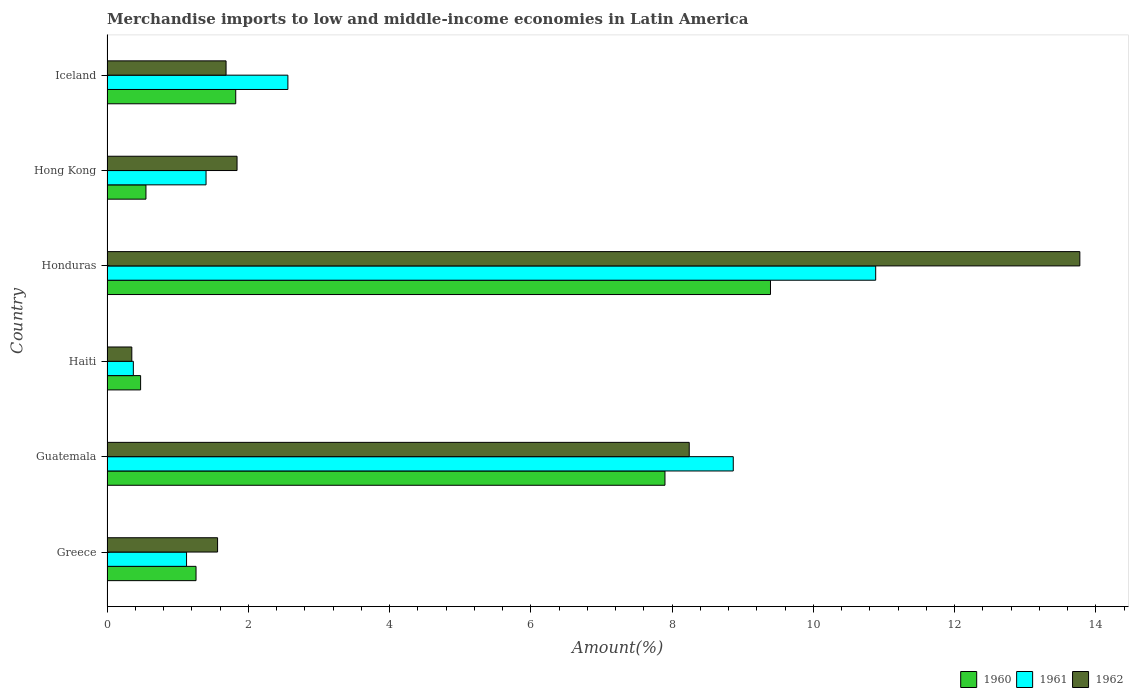How many different coloured bars are there?
Your answer should be compact. 3. How many groups of bars are there?
Make the answer very short. 6. How many bars are there on the 6th tick from the top?
Your answer should be very brief. 3. What is the label of the 2nd group of bars from the top?
Provide a short and direct response. Hong Kong. What is the percentage of amount earned from merchandise imports in 1962 in Haiti?
Provide a short and direct response. 0.35. Across all countries, what is the maximum percentage of amount earned from merchandise imports in 1962?
Your response must be concise. 13.77. Across all countries, what is the minimum percentage of amount earned from merchandise imports in 1961?
Offer a terse response. 0.37. In which country was the percentage of amount earned from merchandise imports in 1960 maximum?
Ensure brevity in your answer.  Honduras. In which country was the percentage of amount earned from merchandise imports in 1962 minimum?
Make the answer very short. Haiti. What is the total percentage of amount earned from merchandise imports in 1960 in the graph?
Your response must be concise. 21.4. What is the difference between the percentage of amount earned from merchandise imports in 1960 in Greece and that in Honduras?
Provide a short and direct response. -8.13. What is the difference between the percentage of amount earned from merchandise imports in 1960 in Honduras and the percentage of amount earned from merchandise imports in 1962 in Iceland?
Offer a terse response. 7.71. What is the average percentage of amount earned from merchandise imports in 1961 per country?
Make the answer very short. 4.2. What is the difference between the percentage of amount earned from merchandise imports in 1962 and percentage of amount earned from merchandise imports in 1960 in Hong Kong?
Your answer should be very brief. 1.29. In how many countries, is the percentage of amount earned from merchandise imports in 1961 greater than 0.4 %?
Ensure brevity in your answer.  5. What is the ratio of the percentage of amount earned from merchandise imports in 1962 in Greece to that in Honduras?
Provide a succinct answer. 0.11. Is the percentage of amount earned from merchandise imports in 1960 in Haiti less than that in Hong Kong?
Your answer should be very brief. Yes. Is the difference between the percentage of amount earned from merchandise imports in 1962 in Greece and Honduras greater than the difference between the percentage of amount earned from merchandise imports in 1960 in Greece and Honduras?
Give a very brief answer. No. What is the difference between the highest and the second highest percentage of amount earned from merchandise imports in 1962?
Keep it short and to the point. 5.53. What is the difference between the highest and the lowest percentage of amount earned from merchandise imports in 1962?
Make the answer very short. 13.42. What does the 2nd bar from the top in Haiti represents?
Keep it short and to the point. 1961. How many bars are there?
Give a very brief answer. 18. Are all the bars in the graph horizontal?
Provide a short and direct response. Yes. How many countries are there in the graph?
Offer a terse response. 6. Does the graph contain any zero values?
Your answer should be compact. No. What is the title of the graph?
Make the answer very short. Merchandise imports to low and middle-income economies in Latin America. Does "2006" appear as one of the legend labels in the graph?
Your answer should be compact. No. What is the label or title of the X-axis?
Offer a terse response. Amount(%). What is the Amount(%) in 1960 in Greece?
Your response must be concise. 1.26. What is the Amount(%) of 1961 in Greece?
Provide a succinct answer. 1.13. What is the Amount(%) of 1962 in Greece?
Keep it short and to the point. 1.57. What is the Amount(%) in 1960 in Guatemala?
Make the answer very short. 7.9. What is the Amount(%) in 1961 in Guatemala?
Your response must be concise. 8.87. What is the Amount(%) of 1962 in Guatemala?
Offer a terse response. 8.24. What is the Amount(%) in 1960 in Haiti?
Give a very brief answer. 0.48. What is the Amount(%) of 1961 in Haiti?
Give a very brief answer. 0.37. What is the Amount(%) in 1962 in Haiti?
Ensure brevity in your answer.  0.35. What is the Amount(%) of 1960 in Honduras?
Offer a terse response. 9.39. What is the Amount(%) of 1961 in Honduras?
Offer a very short reply. 10.88. What is the Amount(%) in 1962 in Honduras?
Give a very brief answer. 13.77. What is the Amount(%) of 1960 in Hong Kong?
Keep it short and to the point. 0.55. What is the Amount(%) in 1961 in Hong Kong?
Offer a very short reply. 1.4. What is the Amount(%) of 1962 in Hong Kong?
Your answer should be compact. 1.84. What is the Amount(%) in 1960 in Iceland?
Your answer should be very brief. 1.82. What is the Amount(%) in 1961 in Iceland?
Ensure brevity in your answer.  2.56. What is the Amount(%) in 1962 in Iceland?
Provide a short and direct response. 1.69. Across all countries, what is the maximum Amount(%) of 1960?
Keep it short and to the point. 9.39. Across all countries, what is the maximum Amount(%) in 1961?
Make the answer very short. 10.88. Across all countries, what is the maximum Amount(%) in 1962?
Offer a terse response. 13.77. Across all countries, what is the minimum Amount(%) of 1960?
Offer a very short reply. 0.48. Across all countries, what is the minimum Amount(%) of 1961?
Offer a terse response. 0.37. Across all countries, what is the minimum Amount(%) of 1962?
Keep it short and to the point. 0.35. What is the total Amount(%) in 1960 in the graph?
Ensure brevity in your answer.  21.4. What is the total Amount(%) in 1961 in the graph?
Your response must be concise. 25.21. What is the total Amount(%) of 1962 in the graph?
Your response must be concise. 27.46. What is the difference between the Amount(%) of 1960 in Greece and that in Guatemala?
Give a very brief answer. -6.64. What is the difference between the Amount(%) of 1961 in Greece and that in Guatemala?
Keep it short and to the point. -7.74. What is the difference between the Amount(%) of 1962 in Greece and that in Guatemala?
Ensure brevity in your answer.  -6.68. What is the difference between the Amount(%) in 1960 in Greece and that in Haiti?
Provide a succinct answer. 0.78. What is the difference between the Amount(%) in 1961 in Greece and that in Haiti?
Your answer should be very brief. 0.75. What is the difference between the Amount(%) in 1962 in Greece and that in Haiti?
Offer a very short reply. 1.21. What is the difference between the Amount(%) in 1960 in Greece and that in Honduras?
Your answer should be compact. -8.13. What is the difference between the Amount(%) of 1961 in Greece and that in Honduras?
Your response must be concise. -9.76. What is the difference between the Amount(%) of 1962 in Greece and that in Honduras?
Your answer should be very brief. -12.21. What is the difference between the Amount(%) of 1960 in Greece and that in Hong Kong?
Provide a short and direct response. 0.71. What is the difference between the Amount(%) of 1961 in Greece and that in Hong Kong?
Provide a succinct answer. -0.28. What is the difference between the Amount(%) in 1962 in Greece and that in Hong Kong?
Give a very brief answer. -0.28. What is the difference between the Amount(%) in 1960 in Greece and that in Iceland?
Make the answer very short. -0.56. What is the difference between the Amount(%) of 1961 in Greece and that in Iceland?
Offer a very short reply. -1.43. What is the difference between the Amount(%) of 1962 in Greece and that in Iceland?
Provide a succinct answer. -0.12. What is the difference between the Amount(%) of 1960 in Guatemala and that in Haiti?
Your answer should be compact. 7.42. What is the difference between the Amount(%) of 1961 in Guatemala and that in Haiti?
Ensure brevity in your answer.  8.49. What is the difference between the Amount(%) of 1962 in Guatemala and that in Haiti?
Provide a short and direct response. 7.89. What is the difference between the Amount(%) of 1960 in Guatemala and that in Honduras?
Provide a short and direct response. -1.49. What is the difference between the Amount(%) in 1961 in Guatemala and that in Honduras?
Keep it short and to the point. -2.02. What is the difference between the Amount(%) in 1962 in Guatemala and that in Honduras?
Provide a short and direct response. -5.53. What is the difference between the Amount(%) in 1960 in Guatemala and that in Hong Kong?
Provide a succinct answer. 7.35. What is the difference between the Amount(%) of 1961 in Guatemala and that in Hong Kong?
Offer a terse response. 7.46. What is the difference between the Amount(%) of 1962 in Guatemala and that in Hong Kong?
Your answer should be very brief. 6.4. What is the difference between the Amount(%) in 1960 in Guatemala and that in Iceland?
Your answer should be very brief. 6.08. What is the difference between the Amount(%) of 1961 in Guatemala and that in Iceland?
Your response must be concise. 6.3. What is the difference between the Amount(%) of 1962 in Guatemala and that in Iceland?
Provide a succinct answer. 6.56. What is the difference between the Amount(%) of 1960 in Haiti and that in Honduras?
Provide a short and direct response. -8.92. What is the difference between the Amount(%) in 1961 in Haiti and that in Honduras?
Offer a terse response. -10.51. What is the difference between the Amount(%) in 1962 in Haiti and that in Honduras?
Make the answer very short. -13.42. What is the difference between the Amount(%) in 1960 in Haiti and that in Hong Kong?
Provide a short and direct response. -0.08. What is the difference between the Amount(%) of 1961 in Haiti and that in Hong Kong?
Ensure brevity in your answer.  -1.03. What is the difference between the Amount(%) of 1962 in Haiti and that in Hong Kong?
Ensure brevity in your answer.  -1.49. What is the difference between the Amount(%) of 1960 in Haiti and that in Iceland?
Your answer should be compact. -1.35. What is the difference between the Amount(%) of 1961 in Haiti and that in Iceland?
Make the answer very short. -2.19. What is the difference between the Amount(%) in 1962 in Haiti and that in Iceland?
Your answer should be very brief. -1.33. What is the difference between the Amount(%) of 1960 in Honduras and that in Hong Kong?
Provide a short and direct response. 8.84. What is the difference between the Amount(%) in 1961 in Honduras and that in Hong Kong?
Keep it short and to the point. 9.48. What is the difference between the Amount(%) in 1962 in Honduras and that in Hong Kong?
Offer a very short reply. 11.93. What is the difference between the Amount(%) of 1960 in Honduras and that in Iceland?
Your response must be concise. 7.57. What is the difference between the Amount(%) of 1961 in Honduras and that in Iceland?
Offer a terse response. 8.32. What is the difference between the Amount(%) of 1962 in Honduras and that in Iceland?
Your response must be concise. 12.09. What is the difference between the Amount(%) in 1960 in Hong Kong and that in Iceland?
Your answer should be very brief. -1.27. What is the difference between the Amount(%) of 1961 in Hong Kong and that in Iceland?
Your answer should be compact. -1.16. What is the difference between the Amount(%) in 1962 in Hong Kong and that in Iceland?
Your answer should be compact. 0.16. What is the difference between the Amount(%) of 1960 in Greece and the Amount(%) of 1961 in Guatemala?
Provide a succinct answer. -7.61. What is the difference between the Amount(%) in 1960 in Greece and the Amount(%) in 1962 in Guatemala?
Your response must be concise. -6.98. What is the difference between the Amount(%) in 1961 in Greece and the Amount(%) in 1962 in Guatemala?
Your answer should be compact. -7.12. What is the difference between the Amount(%) in 1960 in Greece and the Amount(%) in 1961 in Haiti?
Give a very brief answer. 0.89. What is the difference between the Amount(%) of 1960 in Greece and the Amount(%) of 1962 in Haiti?
Offer a very short reply. 0.91. What is the difference between the Amount(%) in 1961 in Greece and the Amount(%) in 1962 in Haiti?
Offer a very short reply. 0.77. What is the difference between the Amount(%) in 1960 in Greece and the Amount(%) in 1961 in Honduras?
Offer a terse response. -9.62. What is the difference between the Amount(%) of 1960 in Greece and the Amount(%) of 1962 in Honduras?
Give a very brief answer. -12.51. What is the difference between the Amount(%) of 1961 in Greece and the Amount(%) of 1962 in Honduras?
Ensure brevity in your answer.  -12.65. What is the difference between the Amount(%) of 1960 in Greece and the Amount(%) of 1961 in Hong Kong?
Offer a terse response. -0.14. What is the difference between the Amount(%) of 1960 in Greece and the Amount(%) of 1962 in Hong Kong?
Your answer should be very brief. -0.58. What is the difference between the Amount(%) of 1961 in Greece and the Amount(%) of 1962 in Hong Kong?
Offer a very short reply. -0.71. What is the difference between the Amount(%) of 1960 in Greece and the Amount(%) of 1961 in Iceland?
Your response must be concise. -1.3. What is the difference between the Amount(%) in 1960 in Greece and the Amount(%) in 1962 in Iceland?
Keep it short and to the point. -0.43. What is the difference between the Amount(%) of 1961 in Greece and the Amount(%) of 1962 in Iceland?
Offer a terse response. -0.56. What is the difference between the Amount(%) in 1960 in Guatemala and the Amount(%) in 1961 in Haiti?
Your response must be concise. 7.53. What is the difference between the Amount(%) in 1960 in Guatemala and the Amount(%) in 1962 in Haiti?
Your response must be concise. 7.55. What is the difference between the Amount(%) in 1961 in Guatemala and the Amount(%) in 1962 in Haiti?
Provide a short and direct response. 8.51. What is the difference between the Amount(%) in 1960 in Guatemala and the Amount(%) in 1961 in Honduras?
Ensure brevity in your answer.  -2.98. What is the difference between the Amount(%) in 1960 in Guatemala and the Amount(%) in 1962 in Honduras?
Provide a succinct answer. -5.87. What is the difference between the Amount(%) in 1961 in Guatemala and the Amount(%) in 1962 in Honduras?
Keep it short and to the point. -4.91. What is the difference between the Amount(%) of 1960 in Guatemala and the Amount(%) of 1961 in Hong Kong?
Your response must be concise. 6.5. What is the difference between the Amount(%) of 1960 in Guatemala and the Amount(%) of 1962 in Hong Kong?
Offer a very short reply. 6.06. What is the difference between the Amount(%) in 1961 in Guatemala and the Amount(%) in 1962 in Hong Kong?
Your answer should be very brief. 7.02. What is the difference between the Amount(%) of 1960 in Guatemala and the Amount(%) of 1961 in Iceland?
Provide a succinct answer. 5.34. What is the difference between the Amount(%) of 1960 in Guatemala and the Amount(%) of 1962 in Iceland?
Offer a very short reply. 6.21. What is the difference between the Amount(%) of 1961 in Guatemala and the Amount(%) of 1962 in Iceland?
Provide a succinct answer. 7.18. What is the difference between the Amount(%) in 1960 in Haiti and the Amount(%) in 1961 in Honduras?
Provide a succinct answer. -10.41. What is the difference between the Amount(%) of 1960 in Haiti and the Amount(%) of 1962 in Honduras?
Provide a short and direct response. -13.3. What is the difference between the Amount(%) of 1961 in Haiti and the Amount(%) of 1962 in Honduras?
Ensure brevity in your answer.  -13.4. What is the difference between the Amount(%) of 1960 in Haiti and the Amount(%) of 1961 in Hong Kong?
Provide a short and direct response. -0.93. What is the difference between the Amount(%) of 1960 in Haiti and the Amount(%) of 1962 in Hong Kong?
Keep it short and to the point. -1.37. What is the difference between the Amount(%) in 1961 in Haiti and the Amount(%) in 1962 in Hong Kong?
Keep it short and to the point. -1.47. What is the difference between the Amount(%) in 1960 in Haiti and the Amount(%) in 1961 in Iceland?
Make the answer very short. -2.08. What is the difference between the Amount(%) of 1960 in Haiti and the Amount(%) of 1962 in Iceland?
Offer a very short reply. -1.21. What is the difference between the Amount(%) in 1961 in Haiti and the Amount(%) in 1962 in Iceland?
Make the answer very short. -1.31. What is the difference between the Amount(%) of 1960 in Honduras and the Amount(%) of 1961 in Hong Kong?
Your response must be concise. 7.99. What is the difference between the Amount(%) of 1960 in Honduras and the Amount(%) of 1962 in Hong Kong?
Offer a terse response. 7.55. What is the difference between the Amount(%) in 1961 in Honduras and the Amount(%) in 1962 in Hong Kong?
Your answer should be compact. 9.04. What is the difference between the Amount(%) of 1960 in Honduras and the Amount(%) of 1961 in Iceland?
Provide a succinct answer. 6.83. What is the difference between the Amount(%) of 1960 in Honduras and the Amount(%) of 1962 in Iceland?
Keep it short and to the point. 7.71. What is the difference between the Amount(%) of 1961 in Honduras and the Amount(%) of 1962 in Iceland?
Provide a short and direct response. 9.2. What is the difference between the Amount(%) in 1960 in Hong Kong and the Amount(%) in 1961 in Iceland?
Give a very brief answer. -2.01. What is the difference between the Amount(%) of 1960 in Hong Kong and the Amount(%) of 1962 in Iceland?
Provide a succinct answer. -1.13. What is the difference between the Amount(%) of 1961 in Hong Kong and the Amount(%) of 1962 in Iceland?
Offer a terse response. -0.28. What is the average Amount(%) in 1960 per country?
Keep it short and to the point. 3.57. What is the average Amount(%) in 1961 per country?
Your answer should be very brief. 4.2. What is the average Amount(%) of 1962 per country?
Offer a terse response. 4.58. What is the difference between the Amount(%) of 1960 and Amount(%) of 1961 in Greece?
Keep it short and to the point. 0.13. What is the difference between the Amount(%) of 1960 and Amount(%) of 1962 in Greece?
Provide a succinct answer. -0.3. What is the difference between the Amount(%) of 1961 and Amount(%) of 1962 in Greece?
Provide a short and direct response. -0.44. What is the difference between the Amount(%) in 1960 and Amount(%) in 1961 in Guatemala?
Your response must be concise. -0.97. What is the difference between the Amount(%) in 1960 and Amount(%) in 1962 in Guatemala?
Provide a short and direct response. -0.34. What is the difference between the Amount(%) of 1961 and Amount(%) of 1962 in Guatemala?
Your answer should be very brief. 0.62. What is the difference between the Amount(%) of 1960 and Amount(%) of 1961 in Haiti?
Provide a short and direct response. 0.1. What is the difference between the Amount(%) in 1960 and Amount(%) in 1962 in Haiti?
Offer a terse response. 0.12. What is the difference between the Amount(%) of 1961 and Amount(%) of 1962 in Haiti?
Give a very brief answer. 0.02. What is the difference between the Amount(%) of 1960 and Amount(%) of 1961 in Honduras?
Offer a terse response. -1.49. What is the difference between the Amount(%) in 1960 and Amount(%) in 1962 in Honduras?
Provide a short and direct response. -4.38. What is the difference between the Amount(%) of 1961 and Amount(%) of 1962 in Honduras?
Your answer should be very brief. -2.89. What is the difference between the Amount(%) of 1960 and Amount(%) of 1961 in Hong Kong?
Provide a short and direct response. -0.85. What is the difference between the Amount(%) in 1960 and Amount(%) in 1962 in Hong Kong?
Your response must be concise. -1.29. What is the difference between the Amount(%) of 1961 and Amount(%) of 1962 in Hong Kong?
Provide a succinct answer. -0.44. What is the difference between the Amount(%) in 1960 and Amount(%) in 1961 in Iceland?
Provide a short and direct response. -0.74. What is the difference between the Amount(%) in 1960 and Amount(%) in 1962 in Iceland?
Offer a terse response. 0.14. What is the difference between the Amount(%) of 1961 and Amount(%) of 1962 in Iceland?
Offer a terse response. 0.88. What is the ratio of the Amount(%) of 1960 in Greece to that in Guatemala?
Your response must be concise. 0.16. What is the ratio of the Amount(%) of 1961 in Greece to that in Guatemala?
Offer a very short reply. 0.13. What is the ratio of the Amount(%) of 1962 in Greece to that in Guatemala?
Your answer should be very brief. 0.19. What is the ratio of the Amount(%) in 1960 in Greece to that in Haiti?
Provide a succinct answer. 2.65. What is the ratio of the Amount(%) of 1961 in Greece to that in Haiti?
Keep it short and to the point. 3.02. What is the ratio of the Amount(%) of 1962 in Greece to that in Haiti?
Your answer should be very brief. 4.46. What is the ratio of the Amount(%) in 1960 in Greece to that in Honduras?
Your answer should be compact. 0.13. What is the ratio of the Amount(%) in 1961 in Greece to that in Honduras?
Give a very brief answer. 0.1. What is the ratio of the Amount(%) in 1962 in Greece to that in Honduras?
Provide a short and direct response. 0.11. What is the ratio of the Amount(%) in 1960 in Greece to that in Hong Kong?
Ensure brevity in your answer.  2.29. What is the ratio of the Amount(%) in 1961 in Greece to that in Hong Kong?
Offer a terse response. 0.8. What is the ratio of the Amount(%) in 1962 in Greece to that in Hong Kong?
Offer a very short reply. 0.85. What is the ratio of the Amount(%) in 1960 in Greece to that in Iceland?
Your answer should be very brief. 0.69. What is the ratio of the Amount(%) of 1961 in Greece to that in Iceland?
Your answer should be compact. 0.44. What is the ratio of the Amount(%) in 1962 in Greece to that in Iceland?
Make the answer very short. 0.93. What is the ratio of the Amount(%) in 1960 in Guatemala to that in Haiti?
Give a very brief answer. 16.61. What is the ratio of the Amount(%) in 1961 in Guatemala to that in Haiti?
Give a very brief answer. 23.77. What is the ratio of the Amount(%) in 1962 in Guatemala to that in Haiti?
Offer a very short reply. 23.47. What is the ratio of the Amount(%) in 1960 in Guatemala to that in Honduras?
Provide a short and direct response. 0.84. What is the ratio of the Amount(%) of 1961 in Guatemala to that in Honduras?
Your answer should be very brief. 0.81. What is the ratio of the Amount(%) of 1962 in Guatemala to that in Honduras?
Provide a short and direct response. 0.6. What is the ratio of the Amount(%) of 1960 in Guatemala to that in Hong Kong?
Your answer should be very brief. 14.33. What is the ratio of the Amount(%) of 1961 in Guatemala to that in Hong Kong?
Your answer should be very brief. 6.32. What is the ratio of the Amount(%) of 1962 in Guatemala to that in Hong Kong?
Provide a succinct answer. 4.48. What is the ratio of the Amount(%) in 1960 in Guatemala to that in Iceland?
Ensure brevity in your answer.  4.33. What is the ratio of the Amount(%) of 1961 in Guatemala to that in Iceland?
Make the answer very short. 3.46. What is the ratio of the Amount(%) of 1962 in Guatemala to that in Iceland?
Make the answer very short. 4.89. What is the ratio of the Amount(%) of 1960 in Haiti to that in Honduras?
Make the answer very short. 0.05. What is the ratio of the Amount(%) of 1961 in Haiti to that in Honduras?
Your response must be concise. 0.03. What is the ratio of the Amount(%) of 1962 in Haiti to that in Honduras?
Provide a succinct answer. 0.03. What is the ratio of the Amount(%) in 1960 in Haiti to that in Hong Kong?
Give a very brief answer. 0.86. What is the ratio of the Amount(%) in 1961 in Haiti to that in Hong Kong?
Give a very brief answer. 0.27. What is the ratio of the Amount(%) in 1962 in Haiti to that in Hong Kong?
Make the answer very short. 0.19. What is the ratio of the Amount(%) of 1960 in Haiti to that in Iceland?
Provide a succinct answer. 0.26. What is the ratio of the Amount(%) of 1961 in Haiti to that in Iceland?
Provide a succinct answer. 0.15. What is the ratio of the Amount(%) in 1962 in Haiti to that in Iceland?
Ensure brevity in your answer.  0.21. What is the ratio of the Amount(%) of 1960 in Honduras to that in Hong Kong?
Give a very brief answer. 17.03. What is the ratio of the Amount(%) of 1961 in Honduras to that in Hong Kong?
Ensure brevity in your answer.  7.76. What is the ratio of the Amount(%) in 1962 in Honduras to that in Hong Kong?
Your answer should be compact. 7.48. What is the ratio of the Amount(%) of 1960 in Honduras to that in Iceland?
Keep it short and to the point. 5.15. What is the ratio of the Amount(%) in 1961 in Honduras to that in Iceland?
Your answer should be very brief. 4.25. What is the ratio of the Amount(%) in 1962 in Honduras to that in Iceland?
Provide a short and direct response. 8.17. What is the ratio of the Amount(%) of 1960 in Hong Kong to that in Iceland?
Your answer should be very brief. 0.3. What is the ratio of the Amount(%) of 1961 in Hong Kong to that in Iceland?
Provide a succinct answer. 0.55. What is the ratio of the Amount(%) of 1962 in Hong Kong to that in Iceland?
Ensure brevity in your answer.  1.09. What is the difference between the highest and the second highest Amount(%) in 1960?
Provide a succinct answer. 1.49. What is the difference between the highest and the second highest Amount(%) in 1961?
Give a very brief answer. 2.02. What is the difference between the highest and the second highest Amount(%) of 1962?
Give a very brief answer. 5.53. What is the difference between the highest and the lowest Amount(%) in 1960?
Keep it short and to the point. 8.92. What is the difference between the highest and the lowest Amount(%) of 1961?
Make the answer very short. 10.51. What is the difference between the highest and the lowest Amount(%) of 1962?
Give a very brief answer. 13.42. 